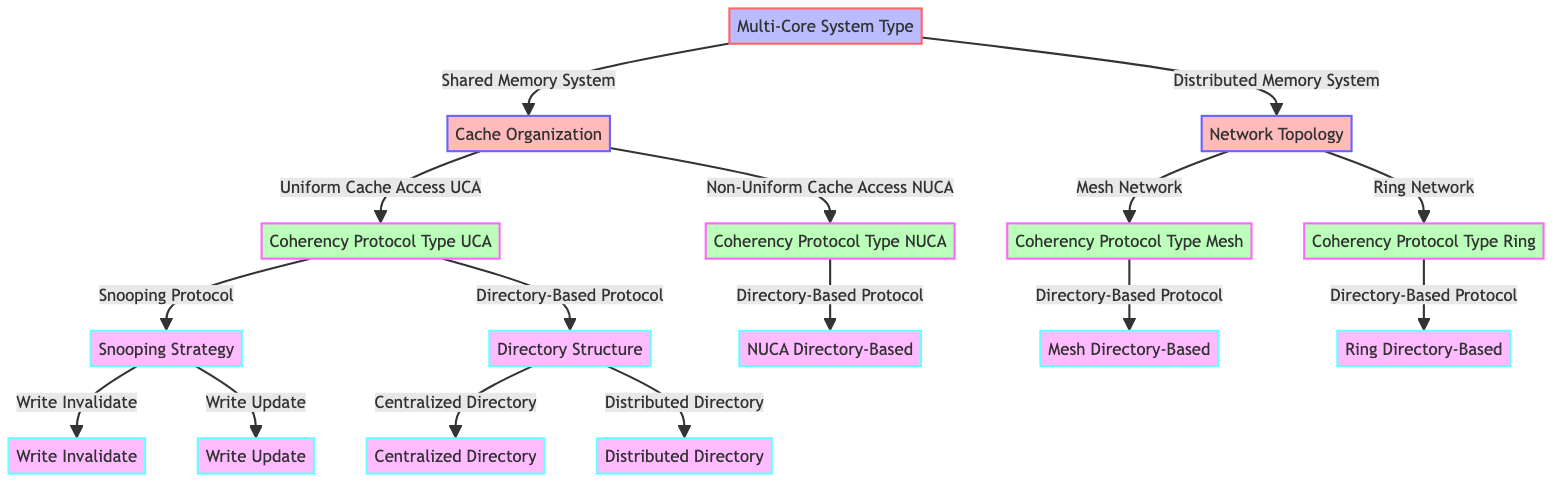What are the two types of multi-core systems? The diagram identifies two types of multi-core systems at the first decision point: Shared Memory System and Distributed Memory System.
Answer: Shared Memory System, Distributed Memory System How many types of cache organization are there under Shared Memory System? In the diagram, under the Shared Memory System, there are two types of cache organization specified: Uniform Cache Access (UCA) and Non-Uniform Cache Access (NUCA).
Answer: 2 What are the two strategies under the Snooping Protocol? The diagram shows that under the Snooping Protocol, there are two strategies available: Write Invalidate and Write Update.
Answer: Write Invalidate, Write Update What is the directory structure for Directory-Based Protocol under Shared Memory and what options does it provide? The diagram indicates that under the Directory-Based Protocol within the Shared Memory System, there are two directory structures available: Centralized Directory and Distributed Directory.
Answer: Centralized Directory, Distributed Directory Which coherency protocol type is applicable for both Mesh and Ring Networks? The diagram indicates that both Mesh Network and Ring Network utilize the Directory-Based Protocol as their coherency protocol type.
Answer: Directory-Based Protocol How many nodes lead to the Write Update strategy? The path to the Write Update strategy flows from Multi-Core System Type to Shared Memory System, then to Cache Organization, and finally through the Sneoping Protocol to Snooping Strategy, where it bifurcates to the Write Invalidate and Write Update options, making a total of 3 nodes leading to Write Update.
Answer: 3 What is the progression of nodes from Shared Memory System to Centralized Directory? The progression starts from Multi-Core System Type to Shared Memory System, then to Cache Organization, followed by Coherency Protocol Type where we arrive at the Directory-Based Protocol; finally, this leads us to Centralized Directory, encompassing a total of four nodes in the pathway.
Answer: 4 How many cache organization options does Non-Uniform Cache Access (NUCA) present? The diagram shows only one option under Non-Uniform Cache Access (NUCA) which is the Directory-Based Protocol.
Answer: 1 What are the two network types in the Distributed Memory System? The diagram outlines two network types under Distributed Memory System: Mesh Network and Ring Network.
Answer: Mesh Network, Ring Network 